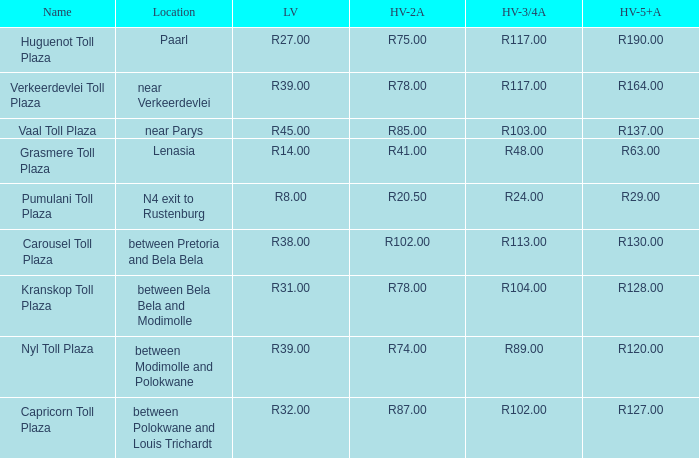What is the name of the plaza where the told for heavy vehicles with 2 axles is r20.50? Pumulani Toll Plaza. 